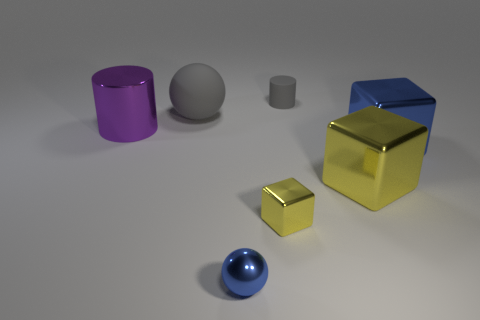What is the shape of the large shiny object behind the blue object that is on the right side of the blue shiny sphere?
Your answer should be compact. Cylinder. There is a large shiny cylinder; what number of balls are behind it?
Your answer should be compact. 1. Is the small gray object made of the same material as the tiny sphere that is in front of the large purple metallic thing?
Your answer should be very brief. No. Are there any blue metal blocks of the same size as the gray matte sphere?
Ensure brevity in your answer.  Yes. Are there an equal number of large yellow blocks right of the small metallic block and large spheres?
Give a very brief answer. Yes. The metal cylinder is what size?
Ensure brevity in your answer.  Large. How many large blue blocks are to the left of the big object on the left side of the large gray rubber sphere?
Give a very brief answer. 0. There is a object that is behind the large cylinder and on the right side of the tiny blue sphere; what is its shape?
Offer a very short reply. Cylinder. How many things have the same color as the tiny metal cube?
Your answer should be very brief. 1. There is a rubber object to the right of the tiny shiny object that is left of the tiny yellow shiny thing; are there any large metallic blocks that are on the left side of it?
Make the answer very short. No. 